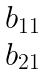<formula> <loc_0><loc_0><loc_500><loc_500>\begin{matrix} b _ { 1 1 } \\ b _ { 2 1 } \end{matrix}</formula> 